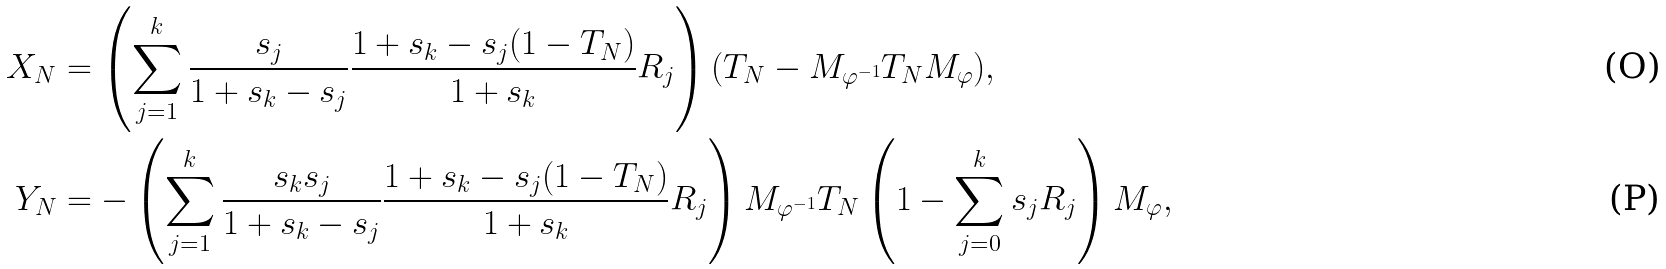<formula> <loc_0><loc_0><loc_500><loc_500>X _ { N } & = \left ( \sum _ { j = 1 } ^ { k } \frac { s _ { j } } { 1 + s _ { k } - s _ { j } } \frac { 1 + s _ { k } - s _ { j } ( 1 - T _ { N } ) } { 1 + s _ { k } } R _ { j } \right ) ( T _ { N } - M _ { \varphi ^ { - 1 } } T _ { N } M _ { \varphi } ) , \\ Y _ { N } & = - \left ( \sum _ { j = 1 } ^ { k } \frac { s _ { k } s _ { j } } { 1 + s _ { k } - s _ { j } } \frac { 1 + s _ { k } - s _ { j } ( 1 - T _ { N } ) } { 1 + s _ { k } } R _ { j } \right ) M _ { \varphi ^ { - 1 } } T _ { N } \left ( 1 - \sum _ { j = 0 } ^ { k } s _ { j } R _ { j } \right ) M _ { \varphi } ,</formula> 